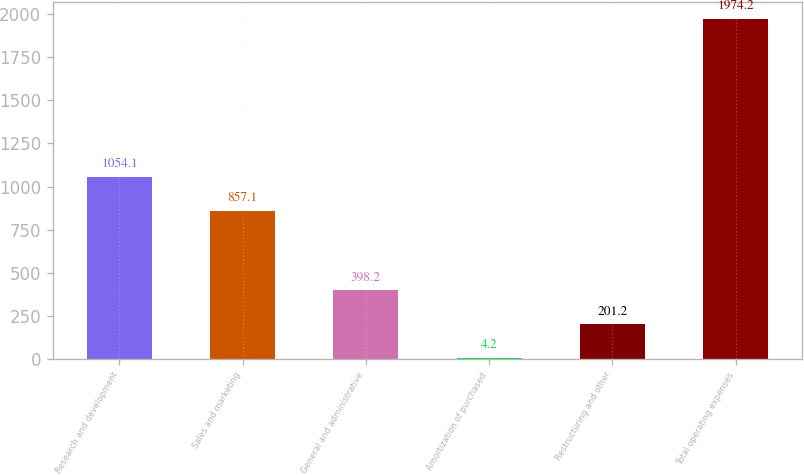Convert chart to OTSL. <chart><loc_0><loc_0><loc_500><loc_500><bar_chart><fcel>Research and development<fcel>Sales and marketing<fcel>General and administrative<fcel>Amortization of purchased<fcel>Restructuring and other<fcel>Total operating expenses<nl><fcel>1054.1<fcel>857.1<fcel>398.2<fcel>4.2<fcel>201.2<fcel>1974.2<nl></chart> 